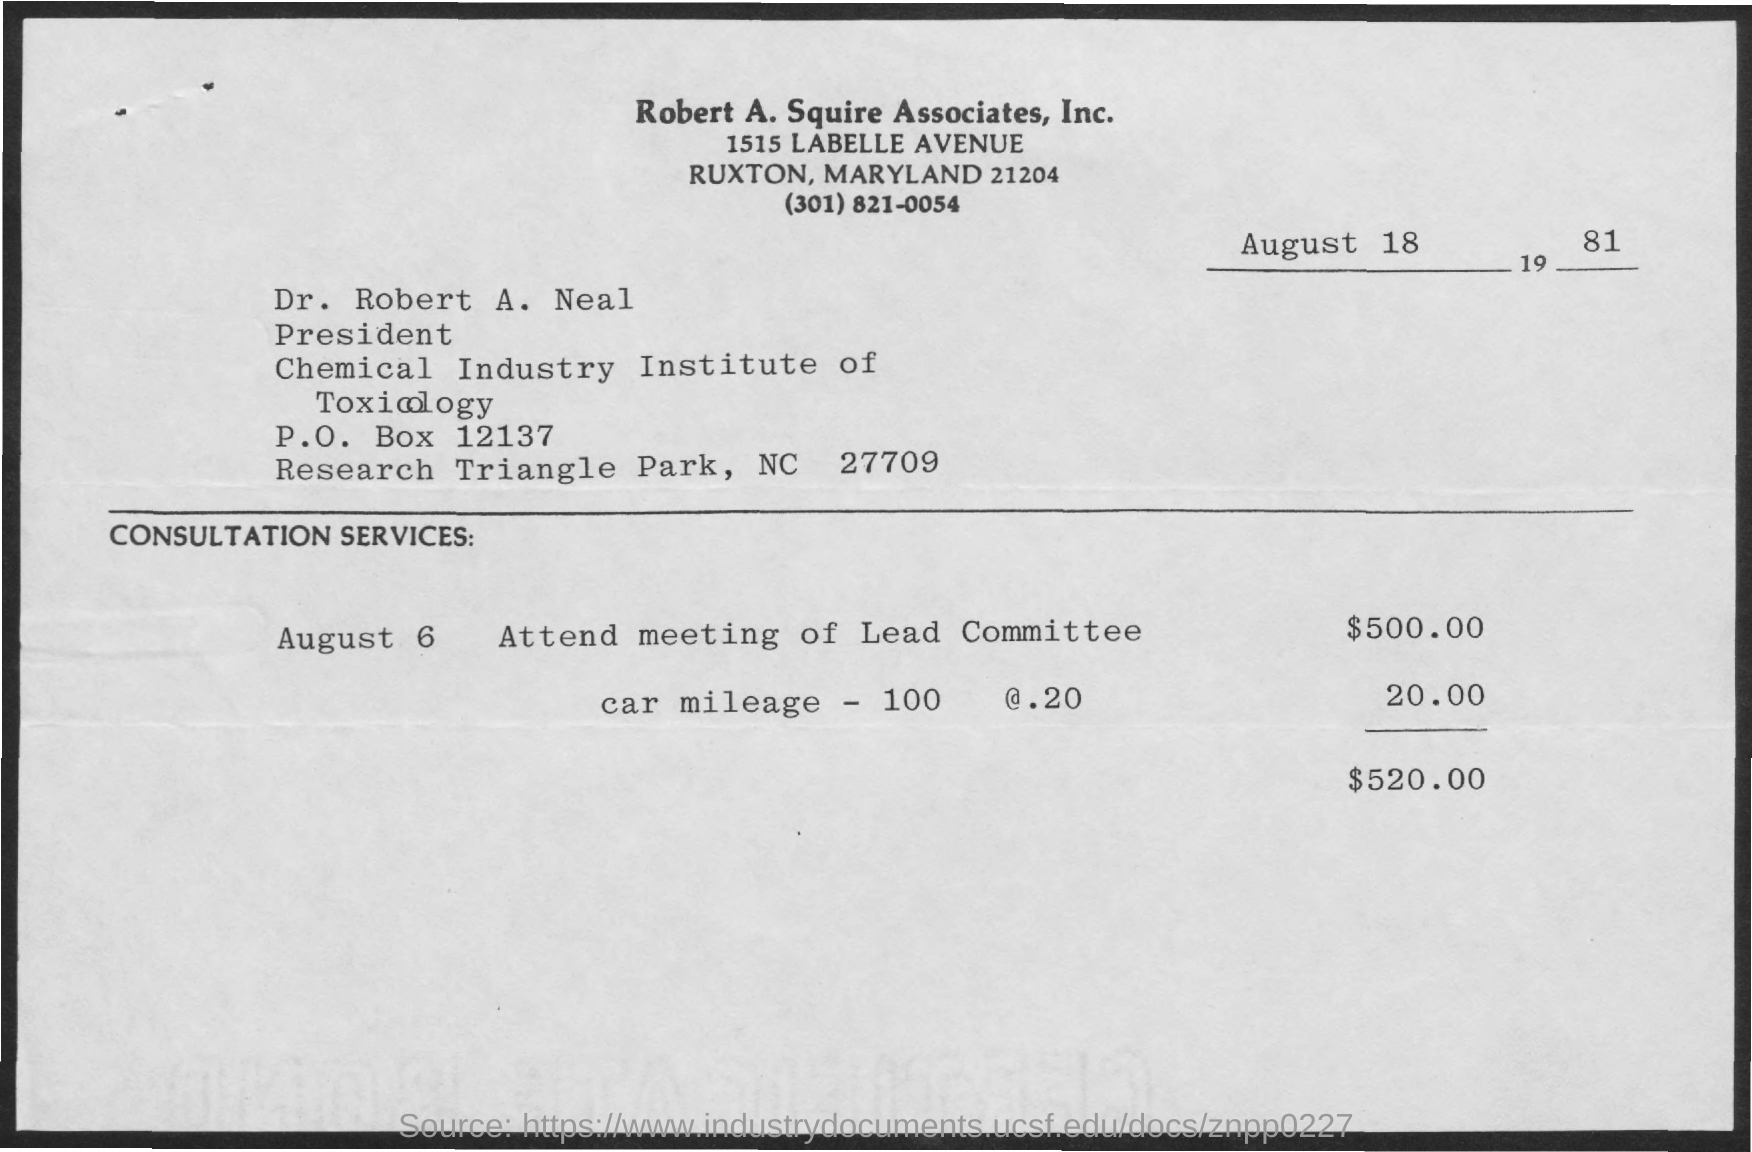What is the date on the document?
Give a very brief answer. August 18 1981. Who is it addressed to?
Provide a succinct answer. Dr. Robert A. Neal. What is the consultation service amount for attending a meeting of lead committee?
Make the answer very short. $500.00. What is the Amount for car mileage - 100 @.20?
Provide a succinct answer. 20.00. What is the Total amount?
Offer a terse response. 520.00. What is the P.O. Box?
Your response must be concise. 12137. 